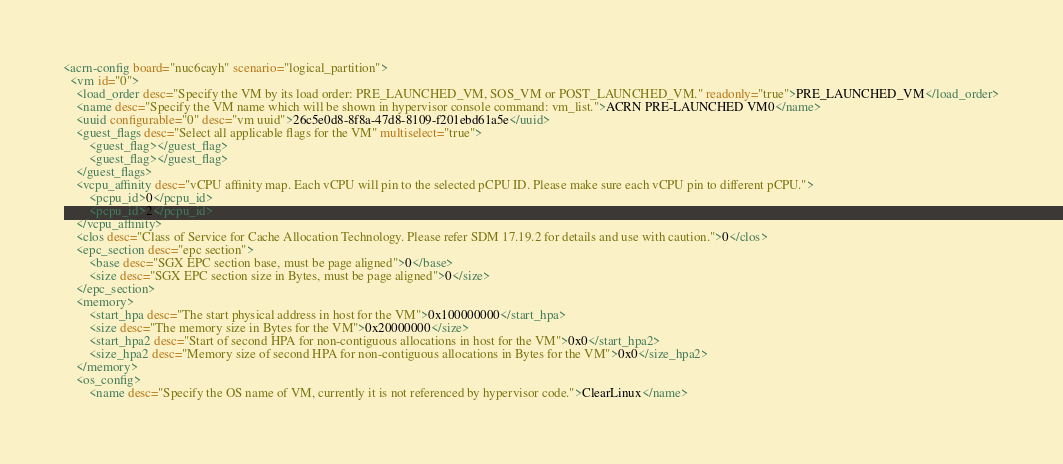Convert code to text. <code><loc_0><loc_0><loc_500><loc_500><_XML_><acrn-config board="nuc6cayh" scenario="logical_partition">
  <vm id="0">
    <load_order desc="Specify the VM by its load order: PRE_LAUNCHED_VM, SOS_VM or POST_LAUNCHED_VM." readonly="true">PRE_LAUNCHED_VM</load_order>
    <name desc="Specify the VM name which will be shown in hypervisor console command: vm_list.">ACRN PRE-LAUNCHED VM0</name>
    <uuid configurable="0" desc="vm uuid">26c5e0d8-8f8a-47d8-8109-f201ebd61a5e</uuid>
    <guest_flags desc="Select all applicable flags for the VM" multiselect="true">
        <guest_flag></guest_flag>
        <guest_flag></guest_flag>
    </guest_flags>
    <vcpu_affinity desc="vCPU affinity map. Each vCPU will pin to the selected pCPU ID. Please make sure each vCPU pin to different pCPU.">
        <pcpu_id>0</pcpu_id>
        <pcpu_id>2</pcpu_id>
    </vcpu_affinity>
    <clos desc="Class of Service for Cache Allocation Technology. Please refer SDM 17.19.2 for details and use with caution.">0</clos>
    <epc_section desc="epc section">
        <base desc="SGX EPC section base, must be page aligned">0</base>
        <size desc="SGX EPC section size in Bytes, must be page aligned">0</size>
    </epc_section>
    <memory>
        <start_hpa desc="The start physical address in host for the VM">0x100000000</start_hpa>
        <size desc="The memory size in Bytes for the VM">0x20000000</size>
        <start_hpa2 desc="Start of second HPA for non-contiguous allocations in host for the VM">0x0</start_hpa2>
        <size_hpa2 desc="Memory size of second HPA for non-contiguous allocations in Bytes for the VM">0x0</size_hpa2>
    </memory>
    <os_config>
        <name desc="Specify the OS name of VM, currently it is not referenced by hypervisor code.">ClearLinux</name></code> 